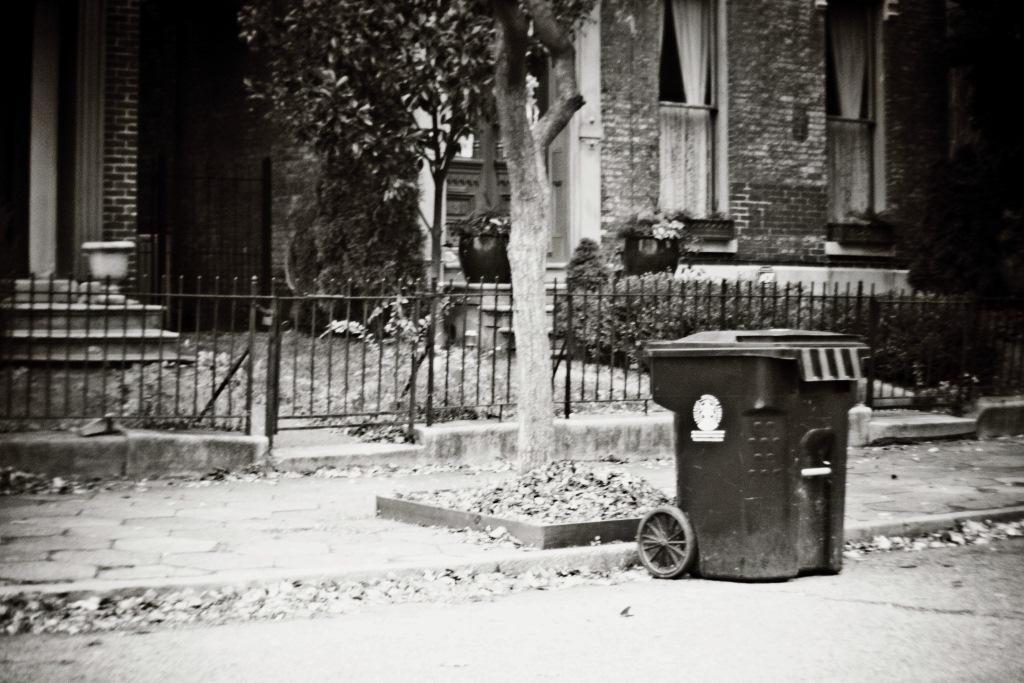What type of structures can be seen in the image? There are buildings in the image. What other natural elements are present in the image? There are trees and plants in the image. What type of barrier can be seen in the image? There is a metal fence in the image. What object is on the ground in the image? There is a dustbin on the ground in the image. How many sisters are playing with the ducks in the image? There are no sisters or ducks present in the image. 